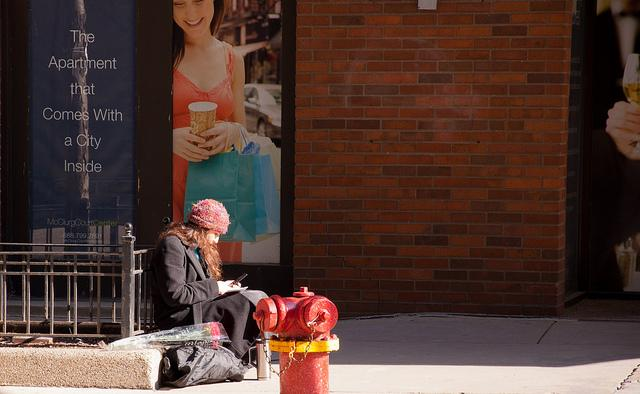What word most closely relates to the red and green things very close to the lady? roses 